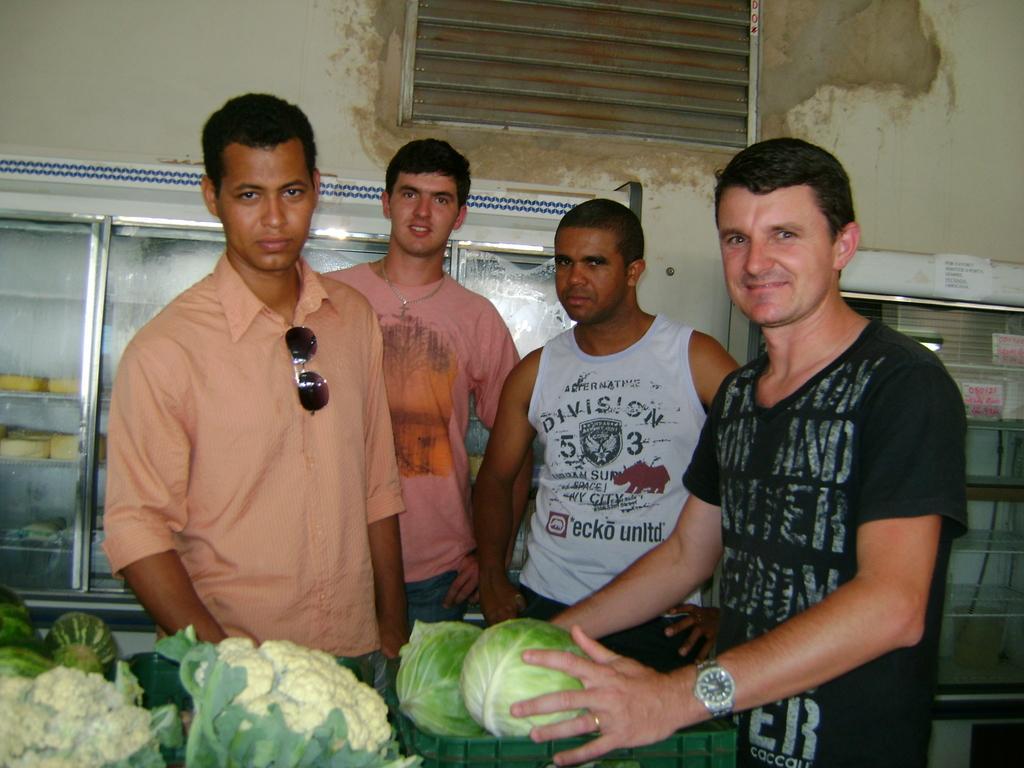Describe this image in one or two sentences. This image consists of four men. In the front, the man wearing black T-shirt is holding a cable. In the background, there are racks in which there are many things. At the top, there is a ventilator along with a wall. 